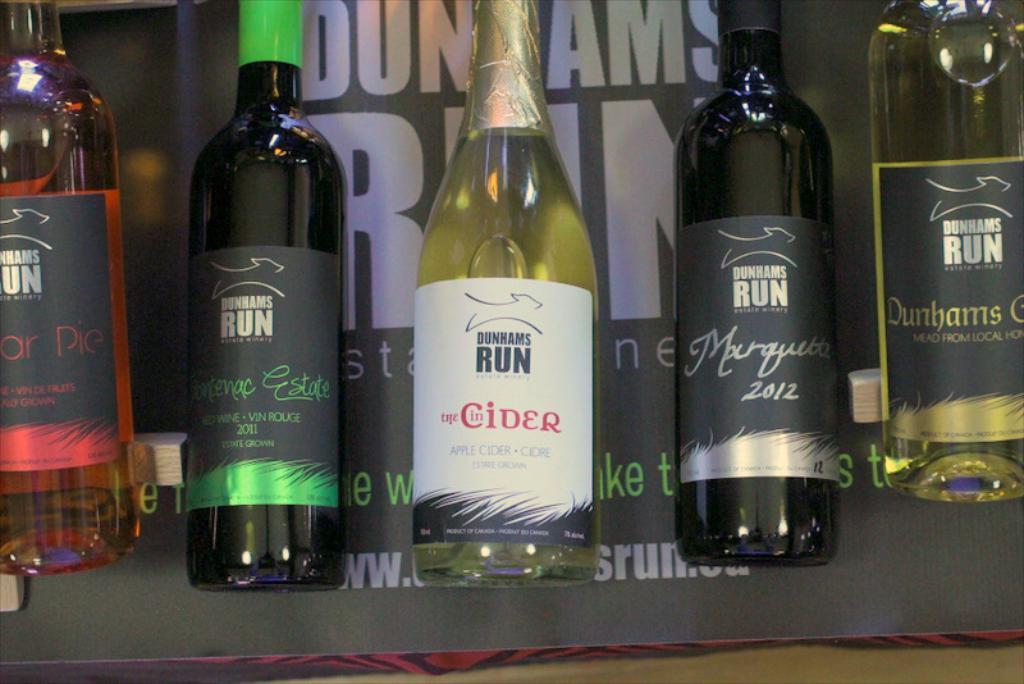What year was the second bottle from the right bottled?
Provide a short and direct response. 2012. 